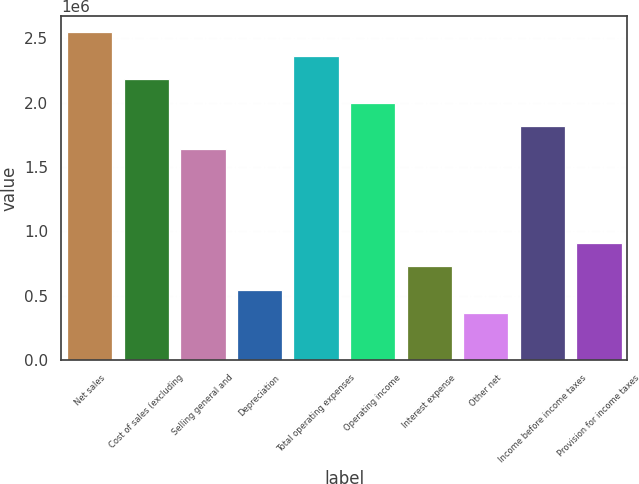<chart> <loc_0><loc_0><loc_500><loc_500><bar_chart><fcel>Net sales<fcel>Cost of sales (excluding<fcel>Selling general and<fcel>Depreciation<fcel>Total operating expenses<fcel>Operating income<fcel>Interest expense<fcel>Other net<fcel>Income before income taxes<fcel>Provision for income taxes<nl><fcel>2.54701e+06<fcel>2.18315e+06<fcel>1.63736e+06<fcel>545788<fcel>2.36508e+06<fcel>2.00122e+06<fcel>727717<fcel>363859<fcel>1.81929e+06<fcel>909646<nl></chart> 